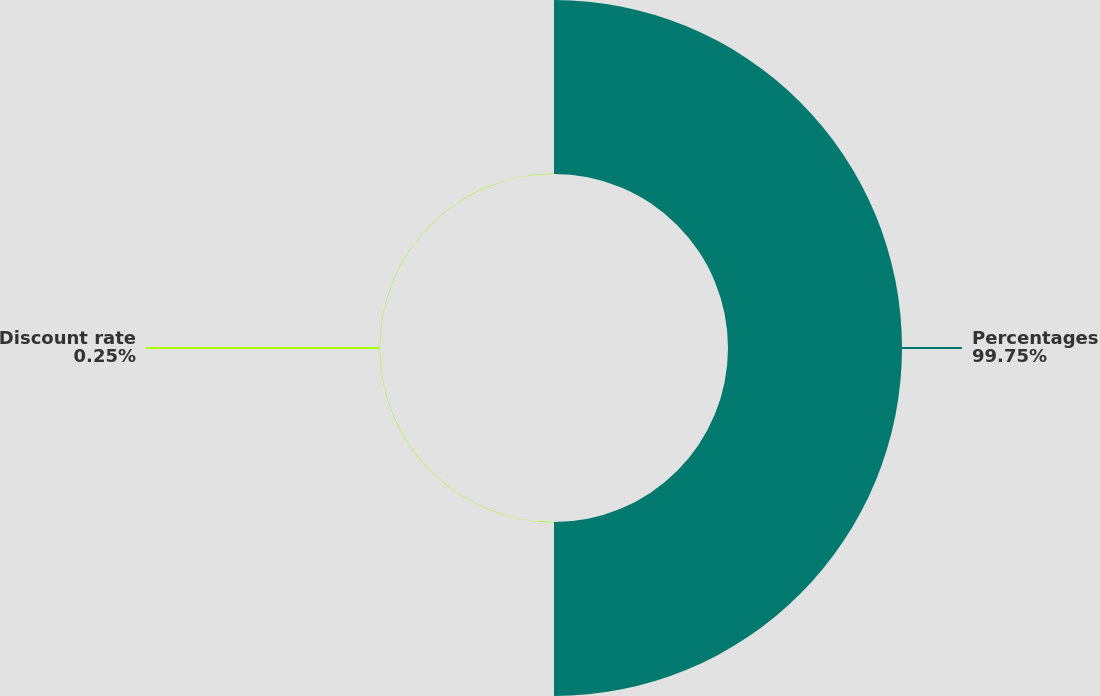Convert chart to OTSL. <chart><loc_0><loc_0><loc_500><loc_500><pie_chart><fcel>Percentages<fcel>Discount rate<nl><fcel>99.75%<fcel>0.25%<nl></chart> 